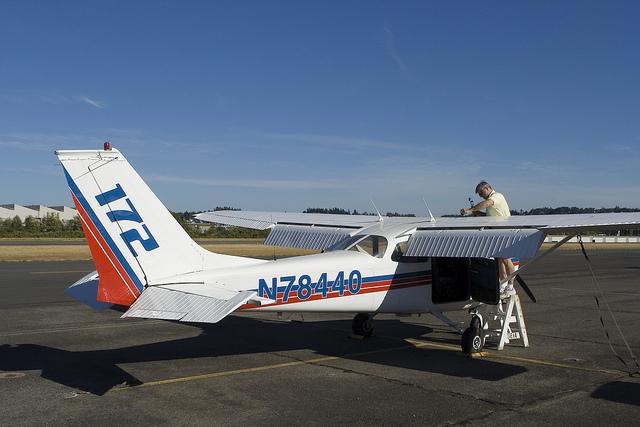Sunny or overcast?
Answer briefly. Sunny. Where is the number 172?
Concise answer only. Tail. What number is shown on the tail and on the side?
Write a very short answer. 172. Is this picture in color?
Give a very brief answer. Yes. What kind of airplane is this?
Be succinct. Small. What is the brand of plane?
Answer briefly. Cessna. What is the tail number of the tricolor plane?
Keep it brief. 172. Is the sky cloudy?
Quick response, please. No. 